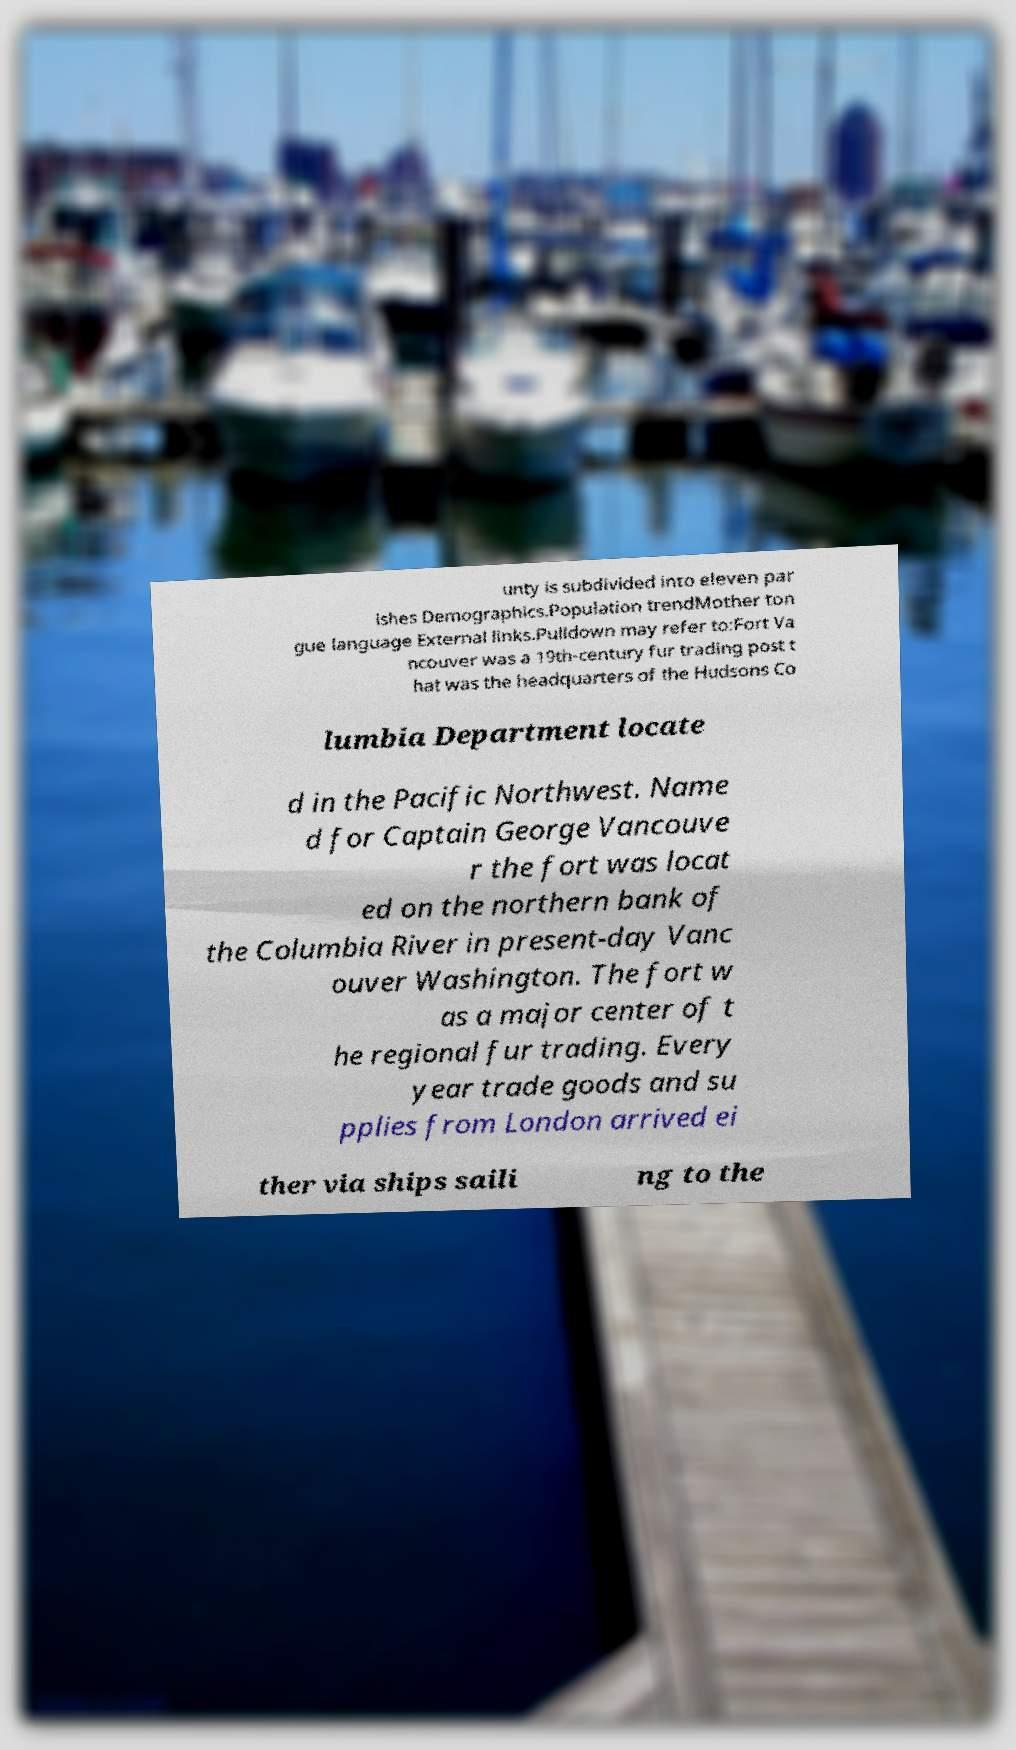Can you read and provide the text displayed in the image?This photo seems to have some interesting text. Can you extract and type it out for me? unty is subdivided into eleven par ishes Demographics.Population trendMother ton gue language External links.Pulldown may refer to:Fort Va ncouver was a 19th-century fur trading post t hat was the headquarters of the Hudsons Co lumbia Department locate d in the Pacific Northwest. Name d for Captain George Vancouve r the fort was locat ed on the northern bank of the Columbia River in present-day Vanc ouver Washington. The fort w as a major center of t he regional fur trading. Every year trade goods and su pplies from London arrived ei ther via ships saili ng to the 